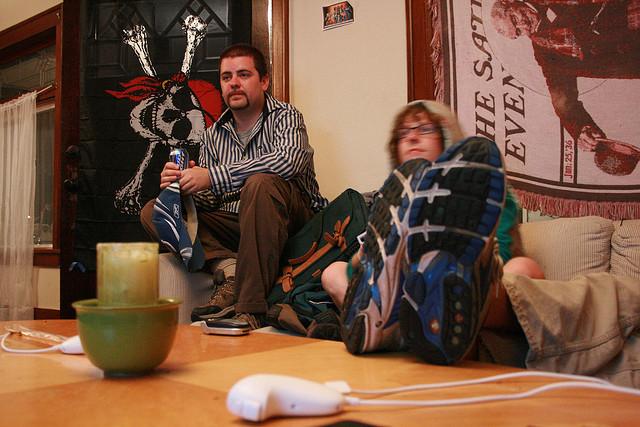Is the man drinking a Coke?
Keep it brief. No. What game system does the remote go to?
Quick response, please. Wii. Is the white object in the foreground a remote control?
Quick response, please. Yes. How many animals are seen?
Keep it brief. 0. Which person is drinking from a can?
Quick response, please. Man. 